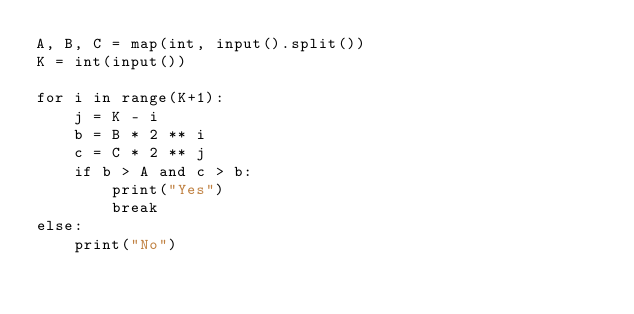Convert code to text. <code><loc_0><loc_0><loc_500><loc_500><_Python_>A, B, C = map(int, input().split())
K = int(input())

for i in range(K+1):
    j = K - i
    b = B * 2 ** i
    c = C * 2 ** j
    if b > A and c > b:
        print("Yes")
        break
else:
    print("No")</code> 